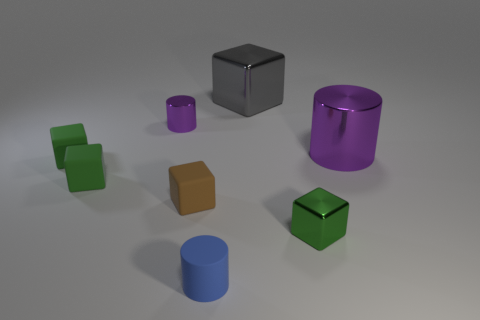Subtract all brown balls. How many green cubes are left? 3 Subtract all brown cubes. How many cubes are left? 4 Subtract all gray blocks. How many blocks are left? 4 Subtract all purple blocks. Subtract all gray cylinders. How many blocks are left? 5 Add 2 large brown rubber spheres. How many objects exist? 10 Subtract all blocks. How many objects are left? 3 Add 4 tiny green matte cubes. How many tiny green matte cubes are left? 6 Add 6 small purple cylinders. How many small purple cylinders exist? 7 Subtract 0 blue cubes. How many objects are left? 8 Subtract all red shiny spheres. Subtract all purple metal cylinders. How many objects are left? 6 